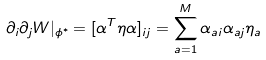Convert formula to latex. <formula><loc_0><loc_0><loc_500><loc_500>\partial _ { i } \partial _ { j } W | _ { \phi ^ { * } } = [ \alpha ^ { T } \eta \alpha ] _ { i j } = \sum _ { a = 1 } ^ { M } \alpha _ { a i } \alpha _ { a j } \eta _ { a }</formula> 